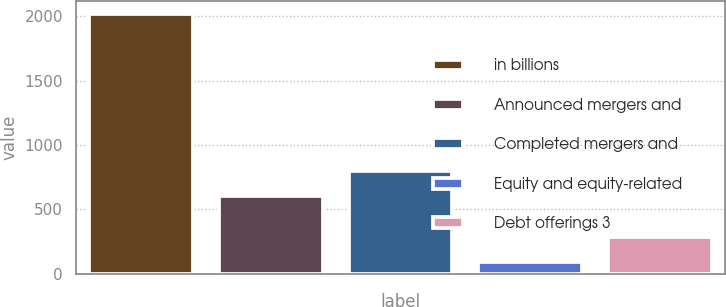Convert chart to OTSL. <chart><loc_0><loc_0><loc_500><loc_500><bar_chart><fcel>in billions<fcel>Announced mergers and<fcel>Completed mergers and<fcel>Equity and equity-related<fcel>Debt offerings 3<nl><fcel>2013<fcel>602<fcel>794.3<fcel>90<fcel>282.3<nl></chart> 